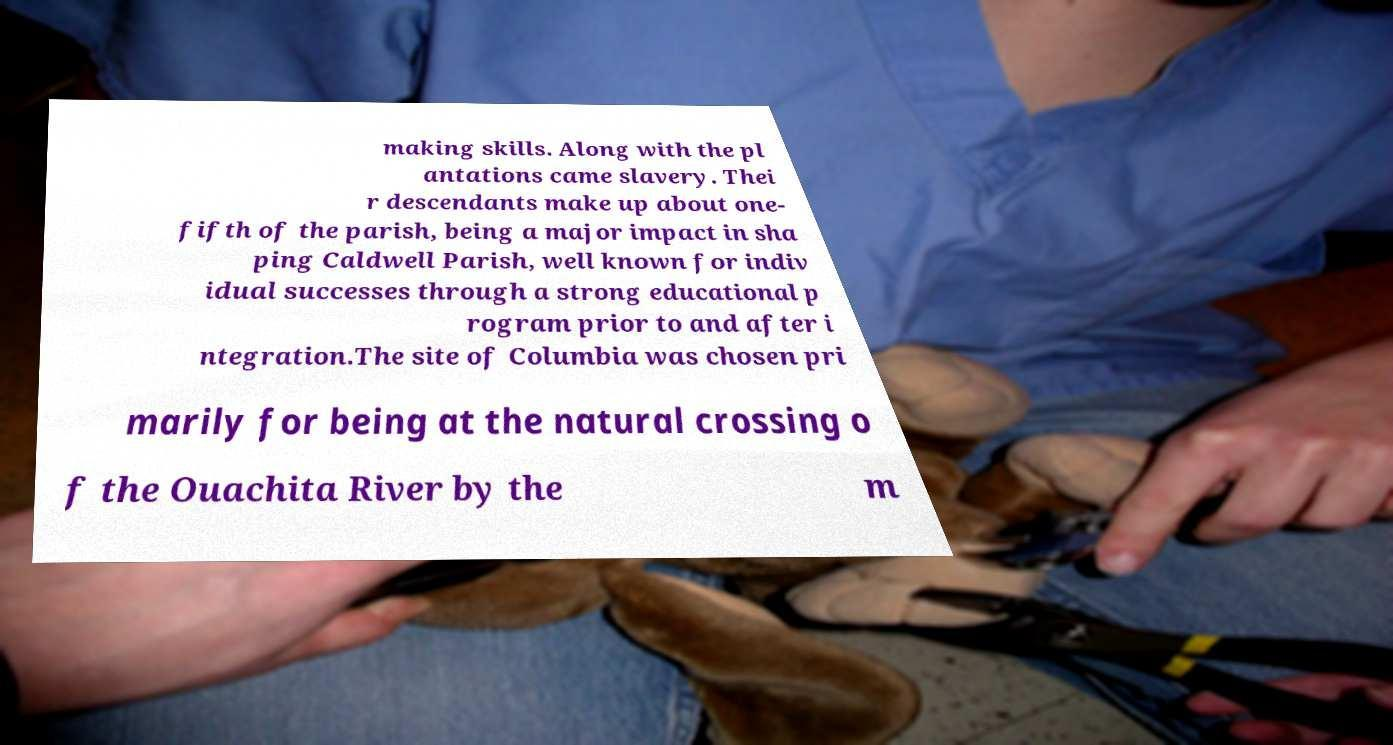What messages or text are displayed in this image? I need them in a readable, typed format. making skills. Along with the pl antations came slavery. Thei r descendants make up about one- fifth of the parish, being a major impact in sha ping Caldwell Parish, well known for indiv idual successes through a strong educational p rogram prior to and after i ntegration.The site of Columbia was chosen pri marily for being at the natural crossing o f the Ouachita River by the m 